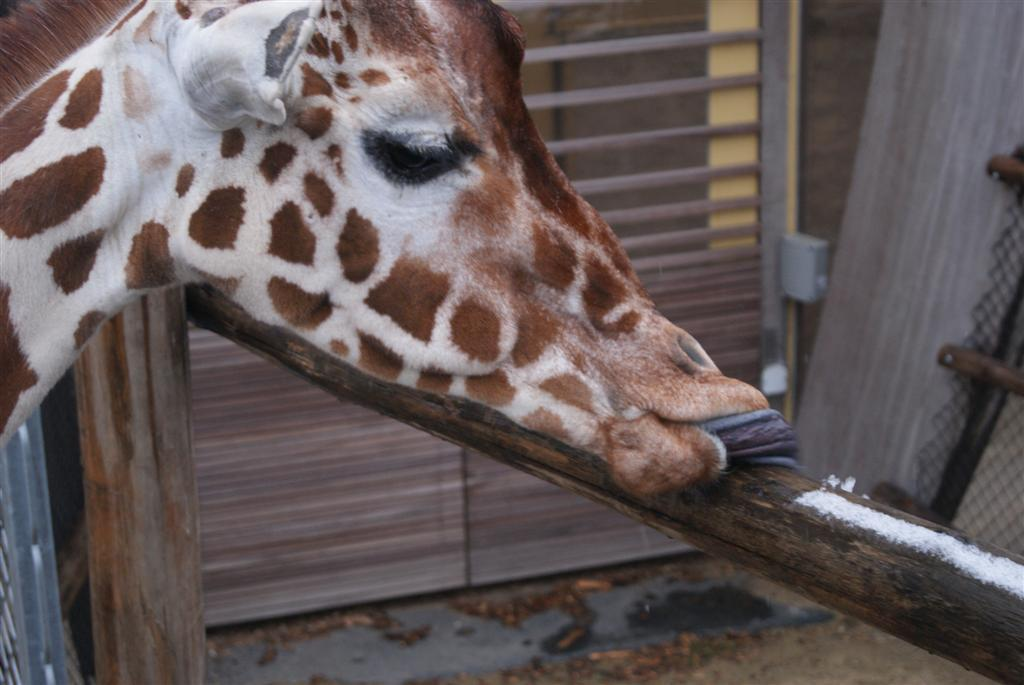What type of animal is in the image? The type of animal cannot be determined from the provided facts. What material are the poles in the image made of? The poles in the image are made of wood. What is the mesh used for in the image? The purpose of the mesh cannot be determined from the provided facts. What are the objects in the image? The objects in the image cannot be determined from the provided facts. What is visible in the background of the image? There is a gate visible in the background of the image. What color is the veil draped over the sand in the image? There is no veil or sand present in the image. 